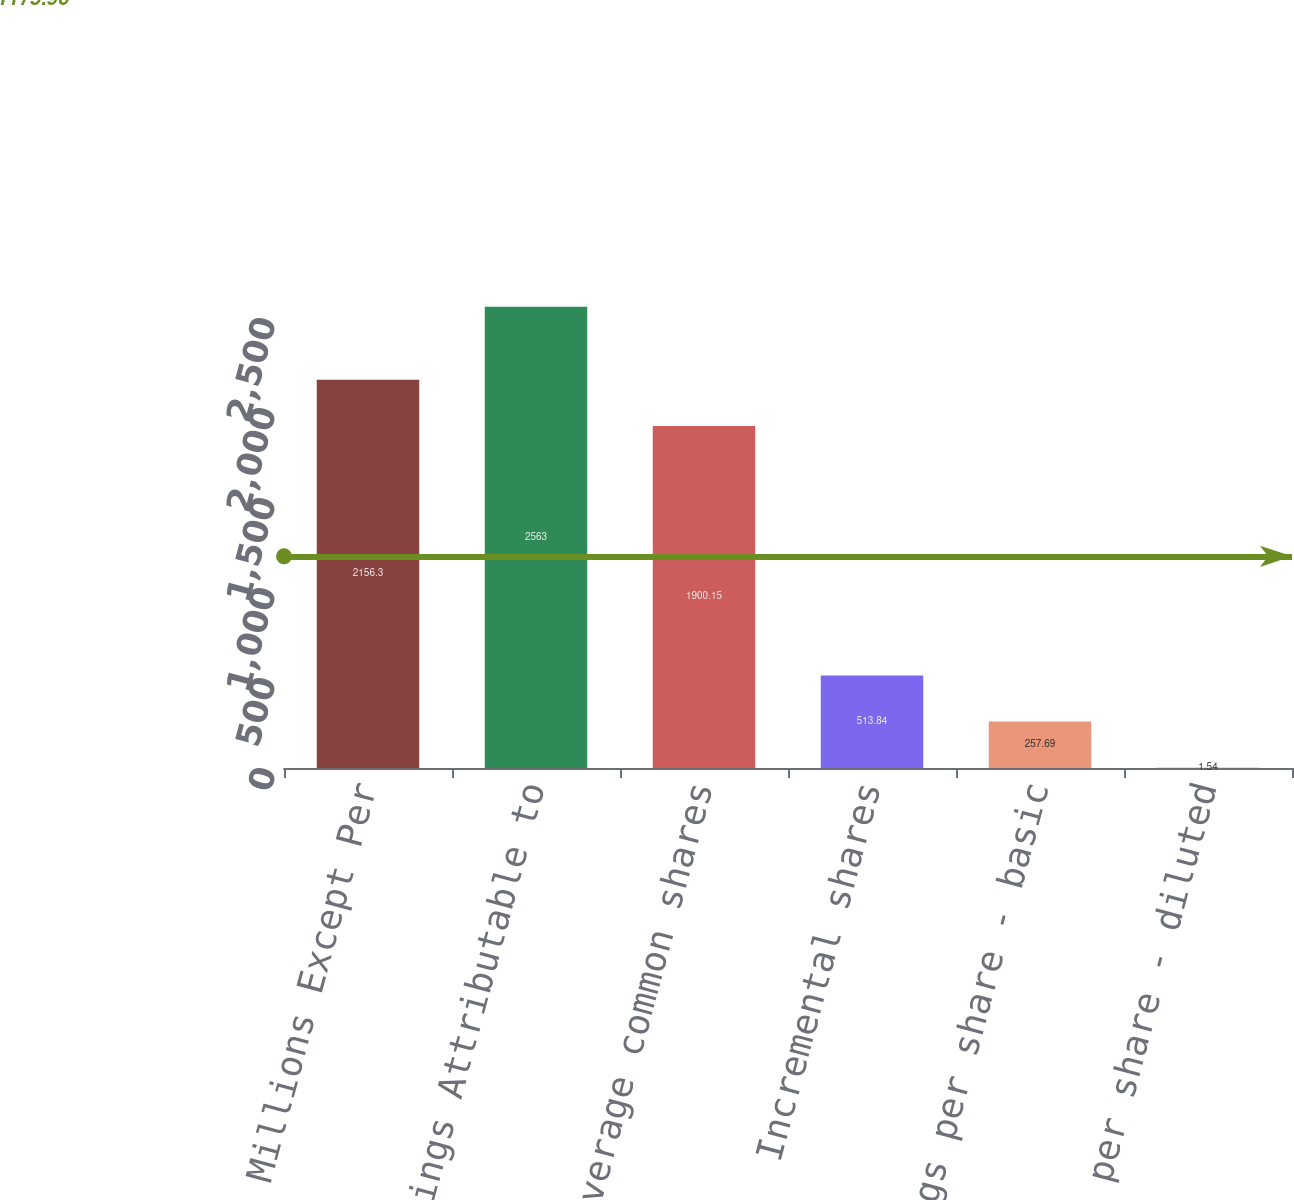Convert chart. <chart><loc_0><loc_0><loc_500><loc_500><bar_chart><fcel>Amounts in Millions Except Per<fcel>Net Earnings Attributable to<fcel>Weighted-average common shares<fcel>Incremental shares<fcel>Earnings per share - basic<fcel>Earnings per share - diluted<nl><fcel>2156.3<fcel>2563<fcel>1900.15<fcel>513.84<fcel>257.69<fcel>1.54<nl></chart> 